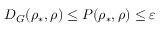Convert formula to latex. <formula><loc_0><loc_0><loc_500><loc_500>D _ { G } ( \rho _ { \ast } , \rho ) \leq P ( \rho _ { \ast } , \rho ) \leq \varepsilon</formula> 